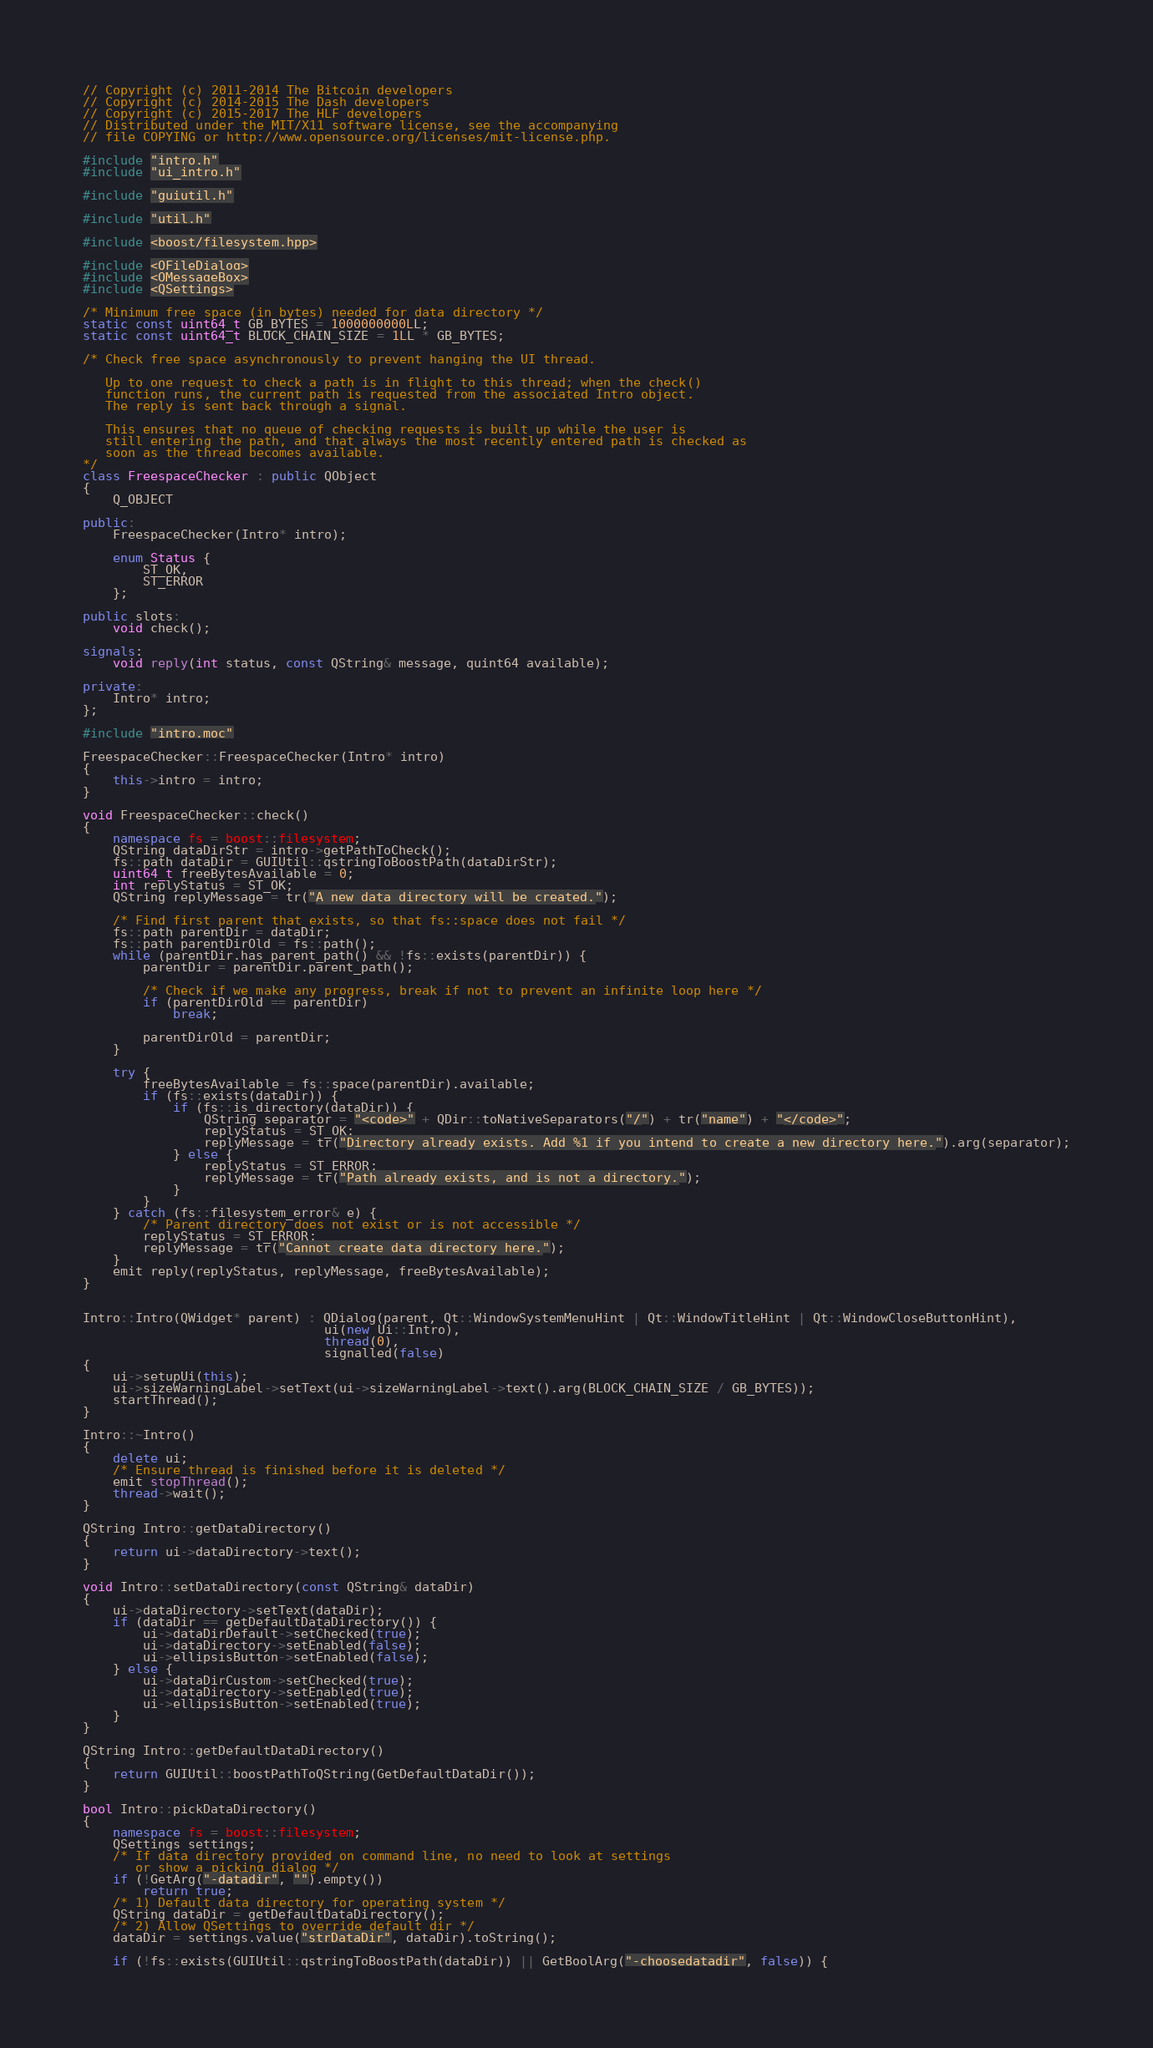Convert code to text. <code><loc_0><loc_0><loc_500><loc_500><_C++_>// Copyright (c) 2011-2014 The Bitcoin developers
// Copyright (c) 2014-2015 The Dash developers
// Copyright (c) 2015-2017 The HLF developers
// Distributed under the MIT/X11 software license, see the accompanying
// file COPYING or http://www.opensource.org/licenses/mit-license.php.

#include "intro.h"
#include "ui_intro.h"

#include "guiutil.h"

#include "util.h"

#include <boost/filesystem.hpp>

#include <QFileDialog>
#include <QMessageBox>
#include <QSettings>

/* Minimum free space (in bytes) needed for data directory */
static const uint64_t GB_BYTES = 1000000000LL;
static const uint64_t BLOCK_CHAIN_SIZE = 1LL * GB_BYTES;

/* Check free space asynchronously to prevent hanging the UI thread.

   Up to one request to check a path is in flight to this thread; when the check()
   function runs, the current path is requested from the associated Intro object.
   The reply is sent back through a signal.

   This ensures that no queue of checking requests is built up while the user is
   still entering the path, and that always the most recently entered path is checked as
   soon as the thread becomes available.
*/
class FreespaceChecker : public QObject
{
    Q_OBJECT

public:
    FreespaceChecker(Intro* intro);

    enum Status {
        ST_OK,
        ST_ERROR
    };

public slots:
    void check();

signals:
    void reply(int status, const QString& message, quint64 available);

private:
    Intro* intro;
};

#include "intro.moc"

FreespaceChecker::FreespaceChecker(Intro* intro)
{
    this->intro = intro;
}

void FreespaceChecker::check()
{
    namespace fs = boost::filesystem;
    QString dataDirStr = intro->getPathToCheck();
    fs::path dataDir = GUIUtil::qstringToBoostPath(dataDirStr);
    uint64_t freeBytesAvailable = 0;
    int replyStatus = ST_OK;
    QString replyMessage = tr("A new data directory will be created.");

    /* Find first parent that exists, so that fs::space does not fail */
    fs::path parentDir = dataDir;
    fs::path parentDirOld = fs::path();
    while (parentDir.has_parent_path() && !fs::exists(parentDir)) {
        parentDir = parentDir.parent_path();

        /* Check if we make any progress, break if not to prevent an infinite loop here */
        if (parentDirOld == parentDir)
            break;

        parentDirOld = parentDir;
    }

    try {
        freeBytesAvailable = fs::space(parentDir).available;
        if (fs::exists(dataDir)) {
            if (fs::is_directory(dataDir)) {
                QString separator = "<code>" + QDir::toNativeSeparators("/") + tr("name") + "</code>";
                replyStatus = ST_OK;
                replyMessage = tr("Directory already exists. Add %1 if you intend to create a new directory here.").arg(separator);
            } else {
                replyStatus = ST_ERROR;
                replyMessage = tr("Path already exists, and is not a directory.");
            }
        }
    } catch (fs::filesystem_error& e) {
        /* Parent directory does not exist or is not accessible */
        replyStatus = ST_ERROR;
        replyMessage = tr("Cannot create data directory here.");
    }
    emit reply(replyStatus, replyMessage, freeBytesAvailable);
}


Intro::Intro(QWidget* parent) : QDialog(parent, Qt::WindowSystemMenuHint | Qt::WindowTitleHint | Qt::WindowCloseButtonHint),
                                ui(new Ui::Intro),
                                thread(0),
                                signalled(false)
{
    ui->setupUi(this);
    ui->sizeWarningLabel->setText(ui->sizeWarningLabel->text().arg(BLOCK_CHAIN_SIZE / GB_BYTES));
    startThread();
}

Intro::~Intro()
{
    delete ui;
    /* Ensure thread is finished before it is deleted */
    emit stopThread();
    thread->wait();
}

QString Intro::getDataDirectory()
{
    return ui->dataDirectory->text();
}

void Intro::setDataDirectory(const QString& dataDir)
{
    ui->dataDirectory->setText(dataDir);
    if (dataDir == getDefaultDataDirectory()) {
        ui->dataDirDefault->setChecked(true);
        ui->dataDirectory->setEnabled(false);
        ui->ellipsisButton->setEnabled(false);
    } else {
        ui->dataDirCustom->setChecked(true);
        ui->dataDirectory->setEnabled(true);
        ui->ellipsisButton->setEnabled(true);
    }
}

QString Intro::getDefaultDataDirectory()
{
    return GUIUtil::boostPathToQString(GetDefaultDataDir());
}

bool Intro::pickDataDirectory()
{
    namespace fs = boost::filesystem;
    QSettings settings;
    /* If data directory provided on command line, no need to look at settings
       or show a picking dialog */
    if (!GetArg("-datadir", "").empty())
        return true;
    /* 1) Default data directory for operating system */
    QString dataDir = getDefaultDataDirectory();
    /* 2) Allow QSettings to override default dir */
    dataDir = settings.value("strDataDir", dataDir).toString();

    if (!fs::exists(GUIUtil::qstringToBoostPath(dataDir)) || GetBoolArg("-choosedatadir", false)) {</code> 